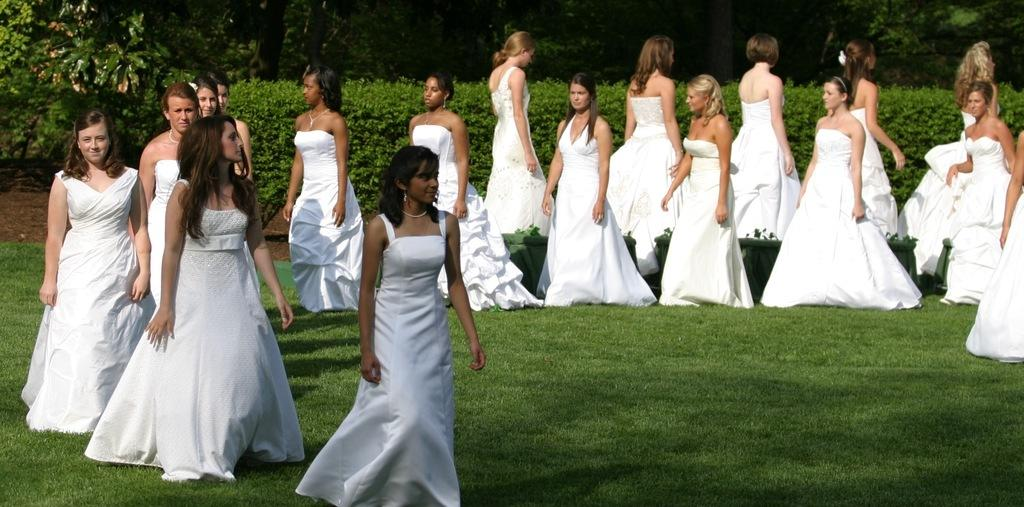Who is present in the image? There are girls in the image. What are the girls wearing? The girls are wearing white dresses. Where are the girls standing? The girls are standing in a garden. What can be seen in the background of the image? There are trees in the background of the image. What reason did the girls have for acting in the image? There is no indication in the image that the girls are acting or have a specific reason for being present. 